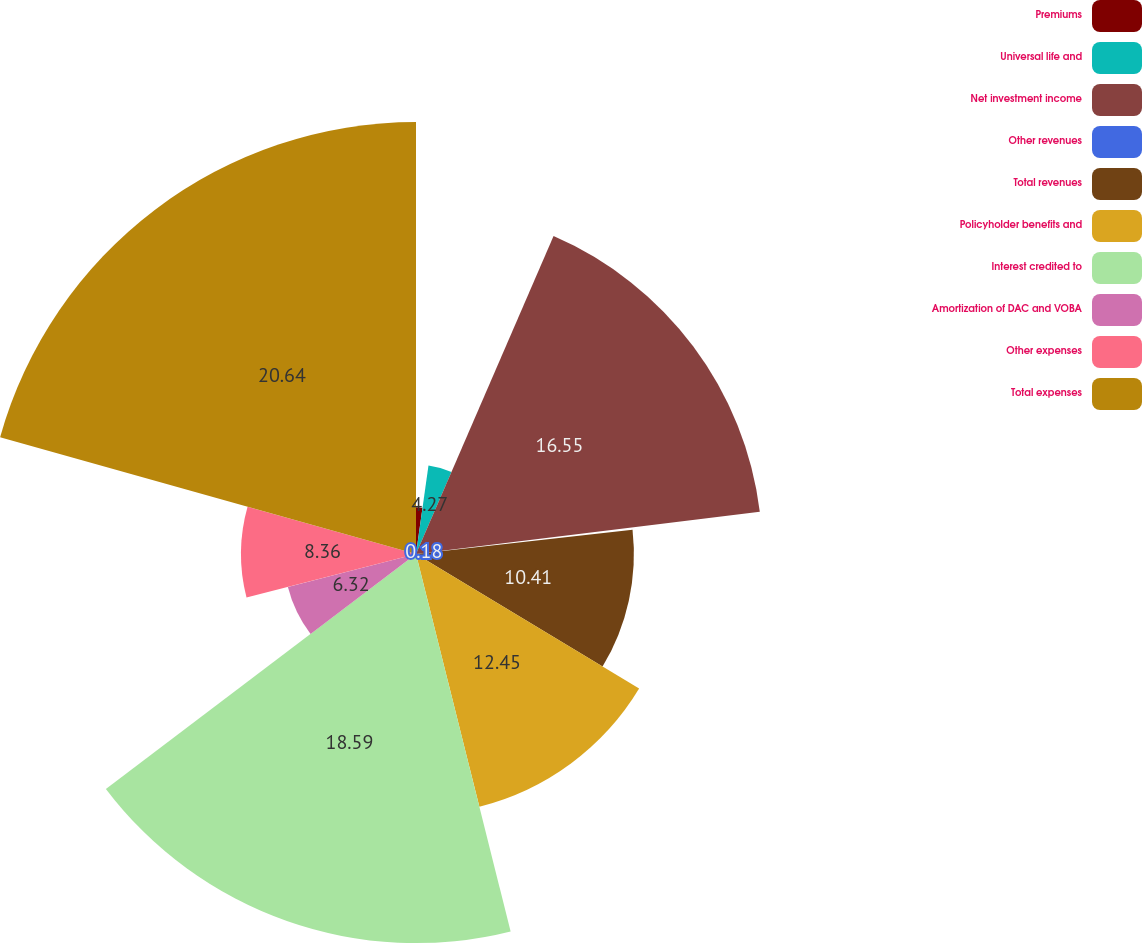Convert chart to OTSL. <chart><loc_0><loc_0><loc_500><loc_500><pie_chart><fcel>Premiums<fcel>Universal life and<fcel>Net investment income<fcel>Other revenues<fcel>Total revenues<fcel>Policyholder benefits and<fcel>Interest credited to<fcel>Amortization of DAC and VOBA<fcel>Other expenses<fcel>Total expenses<nl><fcel>2.23%<fcel>4.27%<fcel>16.55%<fcel>0.18%<fcel>10.41%<fcel>12.45%<fcel>18.59%<fcel>6.32%<fcel>8.36%<fcel>20.64%<nl></chart> 